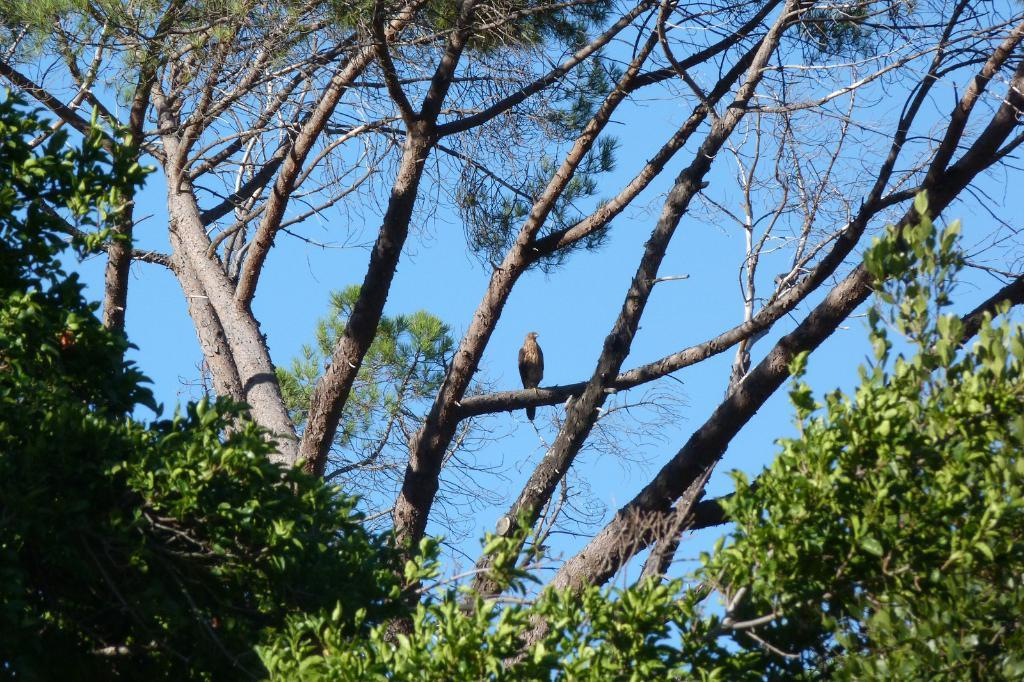What type of animal can be seen in the image? There is a bird in the image. Where is the bird located in the image? The bird is sitting on a branch of a tree. What other objects or features can be seen in the image? There are trees in the image. What can be seen in the background of the image? The sky is visible in the background of the image. How many cakes are being held in the bird's pocket in the image? There are no cakes or pockets present in the image, as it features a bird sitting on a tree branch. 